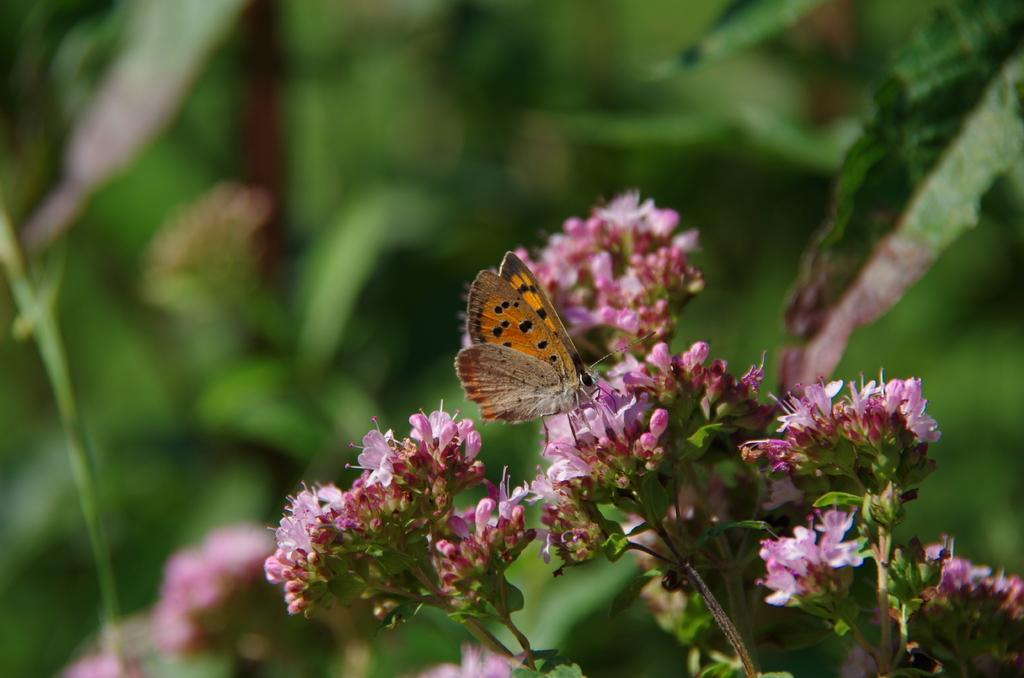What is the main subject of the image? There is a butterfly in the image. What is the butterfly doing in the image? The butterfly is on a pink flower. What color is the butterfly? The butterfly is brown in color. What can be seen in the background of the image? There are other plants visible in the background of the image, but they are blurry. What type of test can be seen being conducted on the pear in the image? There is no test or pear present in the image; it features a brown butterfly on a pink flower. What type of brush is being used to paint the butterfly in the image? There is no brush or painting activity present in the image; it is a photograph of a butterfly on a flower. 